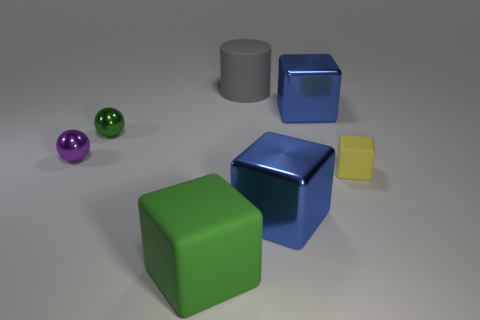Add 2 gray matte blocks. How many objects exist? 9 Subtract all cylinders. How many objects are left? 6 Subtract 1 green cubes. How many objects are left? 6 Subtract all large cubes. Subtract all cylinders. How many objects are left? 3 Add 7 shiny cubes. How many shiny cubes are left? 9 Add 7 purple metal things. How many purple metal things exist? 8 